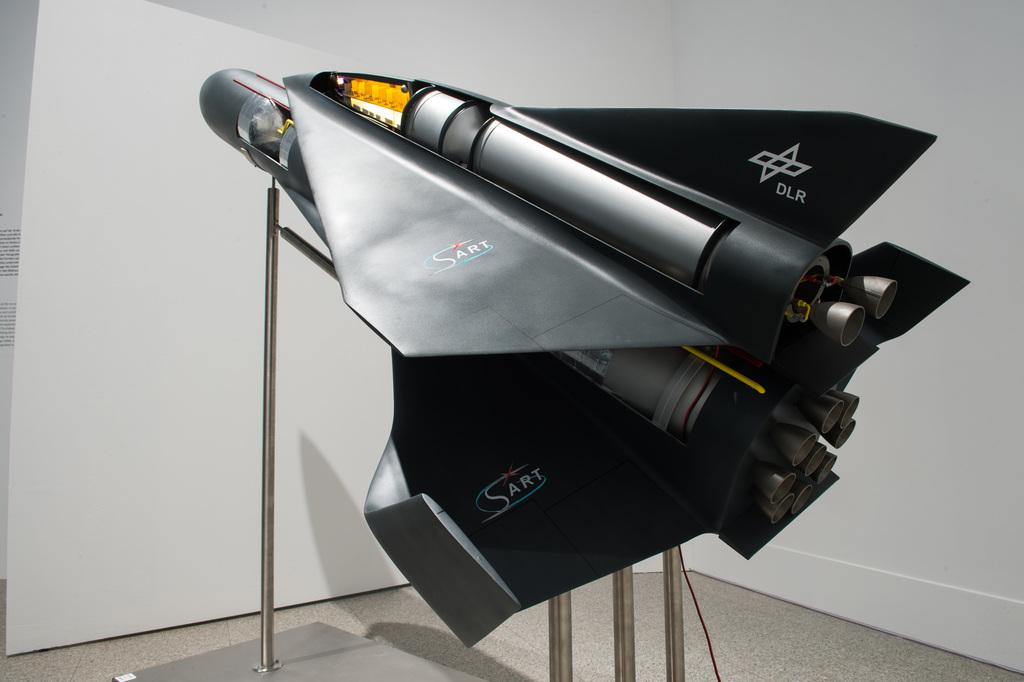<image>
Offer a succinct explanation of the picture presented. A model of a spaceship called the SART DLR. 